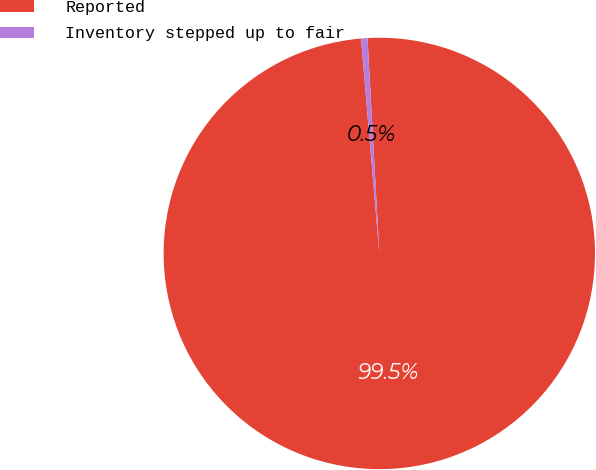Convert chart to OTSL. <chart><loc_0><loc_0><loc_500><loc_500><pie_chart><fcel>Reported<fcel>Inventory stepped up to fair<nl><fcel>99.52%<fcel>0.48%<nl></chart> 